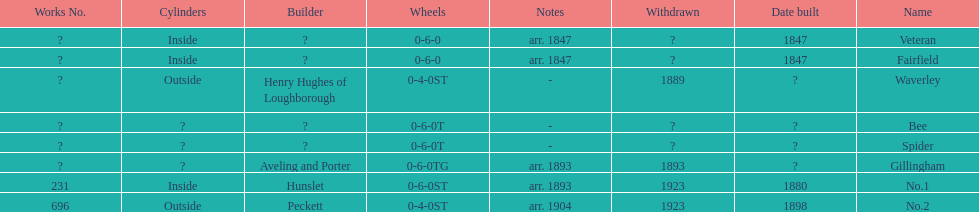How many were built in 1847? 2. 